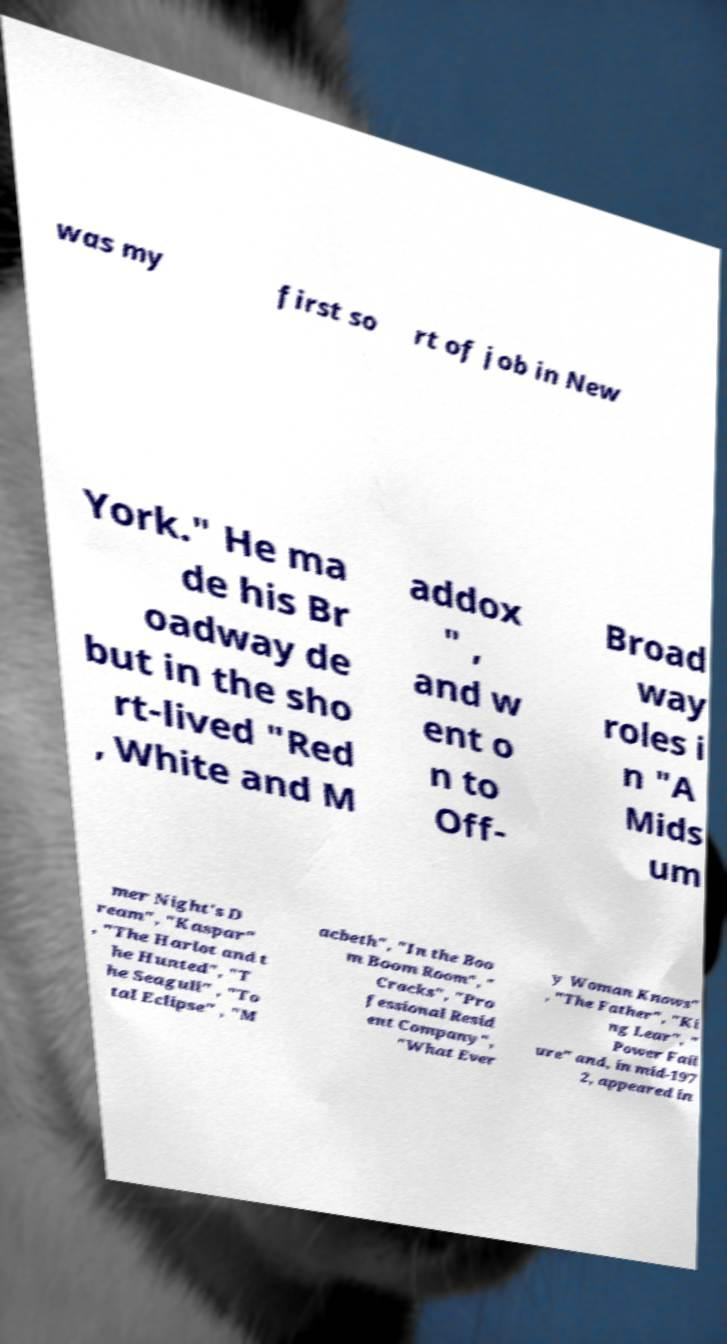Could you extract and type out the text from this image? was my first so rt of job in New York." He ma de his Br oadway de but in the sho rt-lived "Red , White and M addox " , and w ent o n to Off- Broad way roles i n "A Mids um mer Night's D ream", "Kaspar" , "The Harlot and t he Hunted", "T he Seagull" , "To tal Eclipse" , "M acbeth", "In the Boo m Boom Room", " Cracks", "Pro fessional Resid ent Company", "What Ever y Woman Knows" , "The Father", "Ki ng Lear", " Power Fail ure" and, in mid-197 2, appeared in 